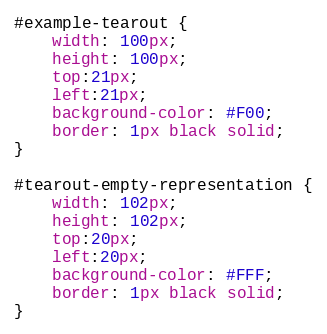<code> <loc_0><loc_0><loc_500><loc_500><_CSS_>#example-tearout {
    width: 100px;
    height: 100px;
    top:21px;
    left:21px;
    background-color: #F00;
    border: 1px black solid;
}

#tearout-empty-representation {
    width: 102px;
    height: 102px;
    top:20px;
    left:20px;
    background-color: #FFF;
    border: 1px black solid;
}</code> 